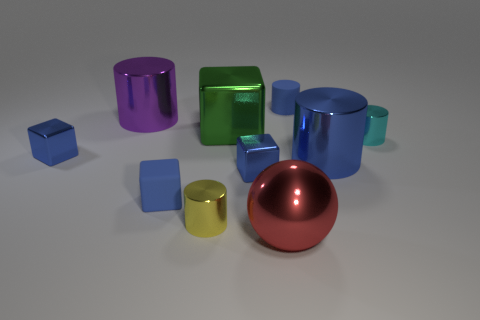Subtract all blue blocks. How many were subtracted if there are2blue blocks left? 1 Subtract all cyan blocks. How many blue cylinders are left? 2 Subtract all cyan cylinders. How many cylinders are left? 4 Subtract all yellow cylinders. How many cylinders are left? 4 Subtract all cyan blocks. Subtract all blue cylinders. How many blocks are left? 4 Subtract all blocks. How many objects are left? 6 Add 8 large blue metal cylinders. How many large blue metal cylinders are left? 9 Add 7 purple blocks. How many purple blocks exist? 7 Subtract 1 yellow cylinders. How many objects are left? 9 Subtract all blue matte blocks. Subtract all metallic things. How many objects are left? 1 